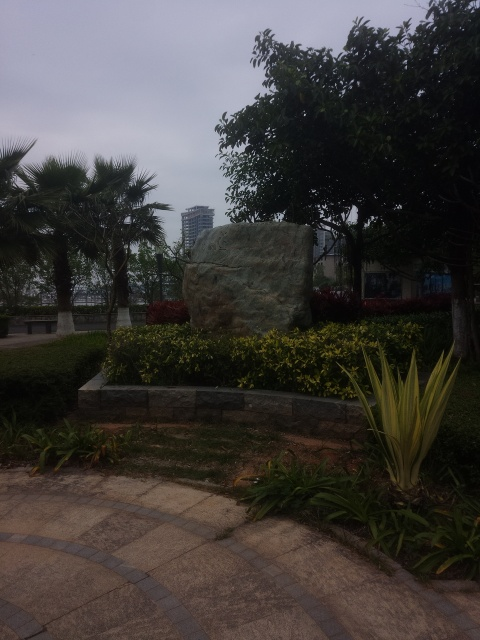Why is the composition not good in the image? The composition of the image could be improved by addressing a few key elements. Firstly, the angle of the shot results in a skewed perspective, making the main subject, the rock, appear unbalanced and less impactful. Secondly, the overwhelming foreground could be minimized to give more focus to the rock. Lastly, adjusting the exposure to brighten the image and enhance color contrasts could also significantly improve the visual appeal. 